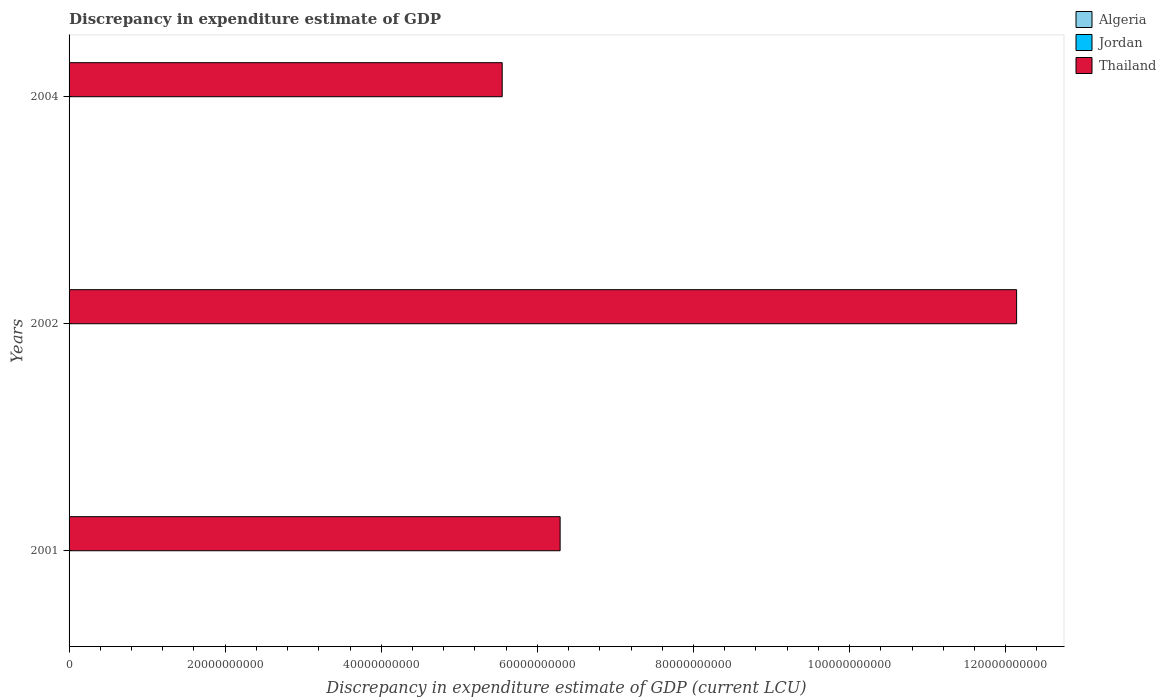How many different coloured bars are there?
Offer a very short reply. 2. Are the number of bars on each tick of the Y-axis equal?
Offer a very short reply. No. How many bars are there on the 1st tick from the bottom?
Give a very brief answer. 1. What is the label of the 2nd group of bars from the top?
Make the answer very short. 2002. In how many cases, is the number of bars for a given year not equal to the number of legend labels?
Keep it short and to the point. 3. What is the discrepancy in expenditure estimate of GDP in Thailand in 2001?
Provide a succinct answer. 6.29e+1. Across all years, what is the maximum discrepancy in expenditure estimate of GDP in Algeria?
Give a very brief answer. 1.00e+05. Across all years, what is the minimum discrepancy in expenditure estimate of GDP in Jordan?
Give a very brief answer. 0. In which year was the discrepancy in expenditure estimate of GDP in Algeria maximum?
Offer a terse response. 2004. What is the total discrepancy in expenditure estimate of GDP in Thailand in the graph?
Your answer should be very brief. 2.40e+11. What is the difference between the discrepancy in expenditure estimate of GDP in Algeria in 2002 and that in 2004?
Offer a terse response. -1.00e+05. What is the difference between the discrepancy in expenditure estimate of GDP in Jordan in 2001 and the discrepancy in expenditure estimate of GDP in Algeria in 2002?
Provide a short and direct response. -0. What is the average discrepancy in expenditure estimate of GDP in Algeria per year?
Your answer should be compact. 3.33e+04. In the year 2004, what is the difference between the discrepancy in expenditure estimate of GDP in Algeria and discrepancy in expenditure estimate of GDP in Thailand?
Your response must be concise. -5.55e+1. What is the ratio of the discrepancy in expenditure estimate of GDP in Thailand in 2002 to that in 2004?
Keep it short and to the point. 2.19. Is the discrepancy in expenditure estimate of GDP in Thailand in 2001 less than that in 2002?
Your answer should be very brief. Yes. Is the difference between the discrepancy in expenditure estimate of GDP in Algeria in 2002 and 2004 greater than the difference between the discrepancy in expenditure estimate of GDP in Thailand in 2002 and 2004?
Provide a succinct answer. No. What is the difference between the highest and the second highest discrepancy in expenditure estimate of GDP in Thailand?
Ensure brevity in your answer.  5.85e+1. What is the difference between the highest and the lowest discrepancy in expenditure estimate of GDP in Thailand?
Make the answer very short. 6.59e+1. Is the sum of the discrepancy in expenditure estimate of GDP in Thailand in 2001 and 2002 greater than the maximum discrepancy in expenditure estimate of GDP in Jordan across all years?
Give a very brief answer. Yes. Is it the case that in every year, the sum of the discrepancy in expenditure estimate of GDP in Thailand and discrepancy in expenditure estimate of GDP in Jordan is greater than the discrepancy in expenditure estimate of GDP in Algeria?
Make the answer very short. Yes. How many bars are there?
Keep it short and to the point. 5. Are all the bars in the graph horizontal?
Offer a very short reply. Yes. What is the difference between two consecutive major ticks on the X-axis?
Your response must be concise. 2.00e+1. How many legend labels are there?
Provide a short and direct response. 3. What is the title of the graph?
Ensure brevity in your answer.  Discrepancy in expenditure estimate of GDP. What is the label or title of the X-axis?
Ensure brevity in your answer.  Discrepancy in expenditure estimate of GDP (current LCU). What is the label or title of the Y-axis?
Your response must be concise. Years. What is the Discrepancy in expenditure estimate of GDP (current LCU) of Thailand in 2001?
Your answer should be very brief. 6.29e+1. What is the Discrepancy in expenditure estimate of GDP (current LCU) of Jordan in 2002?
Provide a succinct answer. 0. What is the Discrepancy in expenditure estimate of GDP (current LCU) in Thailand in 2002?
Make the answer very short. 1.21e+11. What is the Discrepancy in expenditure estimate of GDP (current LCU) in Algeria in 2004?
Keep it short and to the point. 1.00e+05. What is the Discrepancy in expenditure estimate of GDP (current LCU) of Thailand in 2004?
Provide a succinct answer. 5.55e+1. Across all years, what is the maximum Discrepancy in expenditure estimate of GDP (current LCU) of Algeria?
Keep it short and to the point. 1.00e+05. Across all years, what is the maximum Discrepancy in expenditure estimate of GDP (current LCU) of Thailand?
Give a very brief answer. 1.21e+11. Across all years, what is the minimum Discrepancy in expenditure estimate of GDP (current LCU) of Algeria?
Provide a short and direct response. 0. Across all years, what is the minimum Discrepancy in expenditure estimate of GDP (current LCU) in Thailand?
Offer a very short reply. 5.55e+1. What is the total Discrepancy in expenditure estimate of GDP (current LCU) in Algeria in the graph?
Give a very brief answer. 1.00e+05. What is the total Discrepancy in expenditure estimate of GDP (current LCU) of Jordan in the graph?
Make the answer very short. 0. What is the total Discrepancy in expenditure estimate of GDP (current LCU) of Thailand in the graph?
Offer a very short reply. 2.40e+11. What is the difference between the Discrepancy in expenditure estimate of GDP (current LCU) of Thailand in 2001 and that in 2002?
Your answer should be compact. -5.85e+1. What is the difference between the Discrepancy in expenditure estimate of GDP (current LCU) of Thailand in 2001 and that in 2004?
Provide a short and direct response. 7.42e+09. What is the difference between the Discrepancy in expenditure estimate of GDP (current LCU) in Algeria in 2002 and that in 2004?
Ensure brevity in your answer.  -1.00e+05. What is the difference between the Discrepancy in expenditure estimate of GDP (current LCU) of Thailand in 2002 and that in 2004?
Offer a terse response. 6.59e+1. What is the difference between the Discrepancy in expenditure estimate of GDP (current LCU) in Algeria in 2002 and the Discrepancy in expenditure estimate of GDP (current LCU) in Thailand in 2004?
Ensure brevity in your answer.  -5.55e+1. What is the average Discrepancy in expenditure estimate of GDP (current LCU) of Algeria per year?
Give a very brief answer. 3.33e+04. What is the average Discrepancy in expenditure estimate of GDP (current LCU) in Jordan per year?
Offer a very short reply. 0. What is the average Discrepancy in expenditure estimate of GDP (current LCU) in Thailand per year?
Provide a succinct answer. 7.99e+1. In the year 2002, what is the difference between the Discrepancy in expenditure estimate of GDP (current LCU) in Algeria and Discrepancy in expenditure estimate of GDP (current LCU) in Thailand?
Keep it short and to the point. -1.21e+11. In the year 2004, what is the difference between the Discrepancy in expenditure estimate of GDP (current LCU) of Algeria and Discrepancy in expenditure estimate of GDP (current LCU) of Thailand?
Offer a very short reply. -5.55e+1. What is the ratio of the Discrepancy in expenditure estimate of GDP (current LCU) in Thailand in 2001 to that in 2002?
Your answer should be very brief. 0.52. What is the ratio of the Discrepancy in expenditure estimate of GDP (current LCU) of Thailand in 2001 to that in 2004?
Keep it short and to the point. 1.13. What is the ratio of the Discrepancy in expenditure estimate of GDP (current LCU) of Algeria in 2002 to that in 2004?
Make the answer very short. 0. What is the ratio of the Discrepancy in expenditure estimate of GDP (current LCU) in Thailand in 2002 to that in 2004?
Ensure brevity in your answer.  2.19. What is the difference between the highest and the second highest Discrepancy in expenditure estimate of GDP (current LCU) of Thailand?
Keep it short and to the point. 5.85e+1. What is the difference between the highest and the lowest Discrepancy in expenditure estimate of GDP (current LCU) in Algeria?
Make the answer very short. 1.00e+05. What is the difference between the highest and the lowest Discrepancy in expenditure estimate of GDP (current LCU) of Thailand?
Your answer should be very brief. 6.59e+1. 